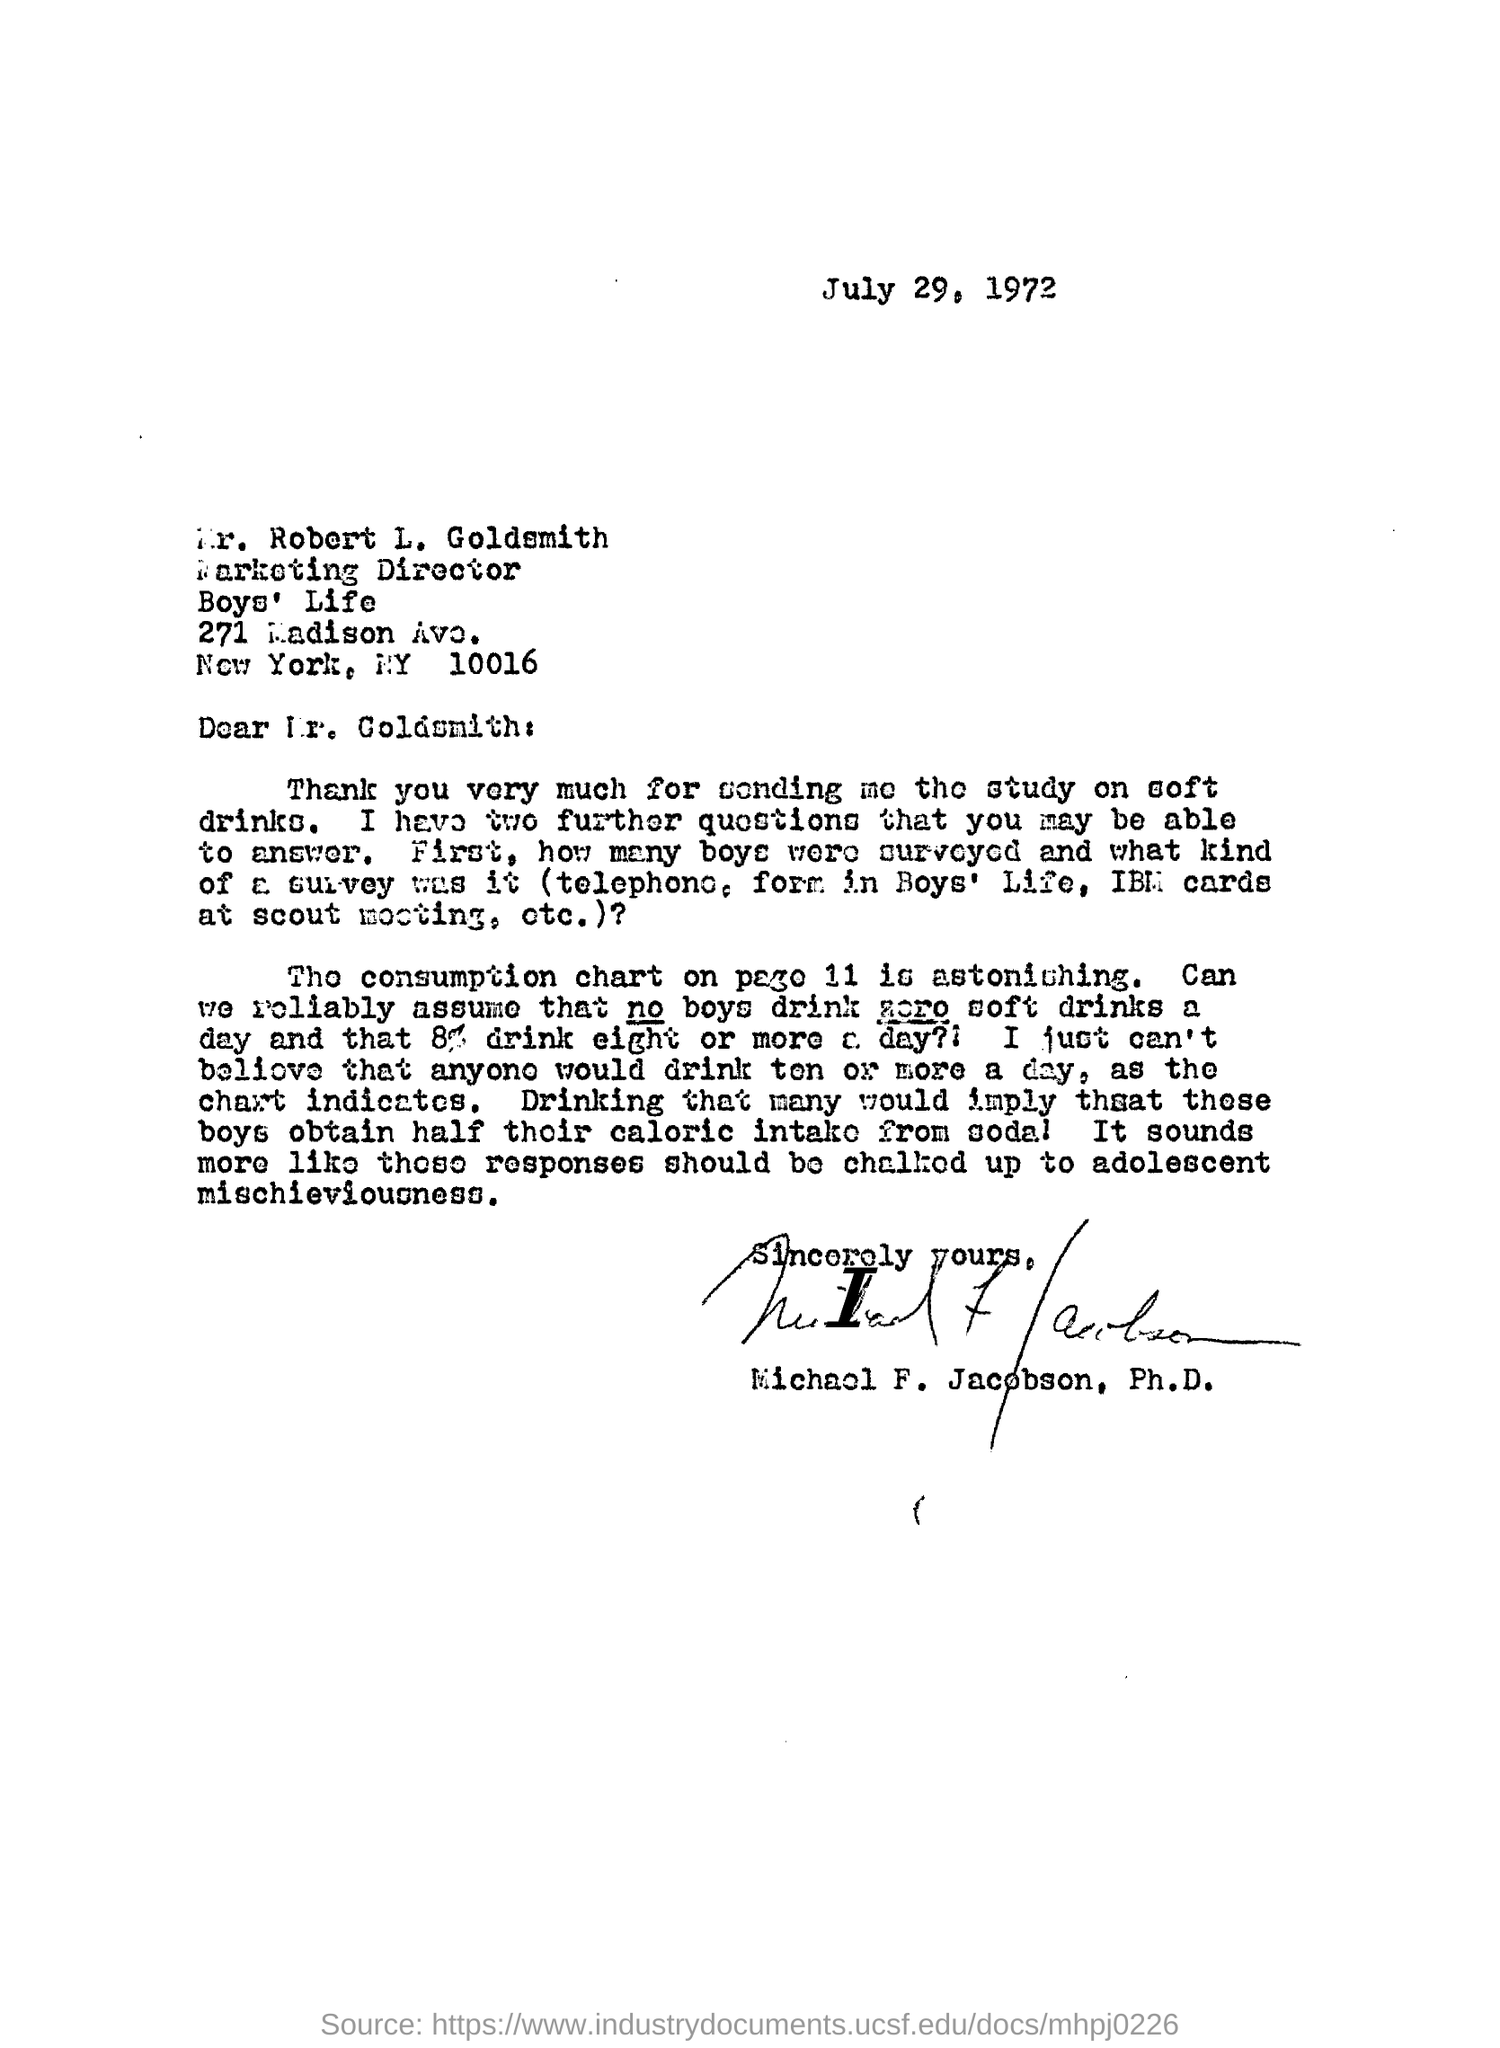Highlight a few significant elements in this photo. The letter mentions a study on soft drinks. The date of this letter is July 29, 1972. The date mentioned on the top of the letter is July 29, 1972. 